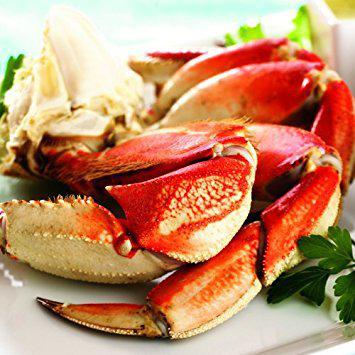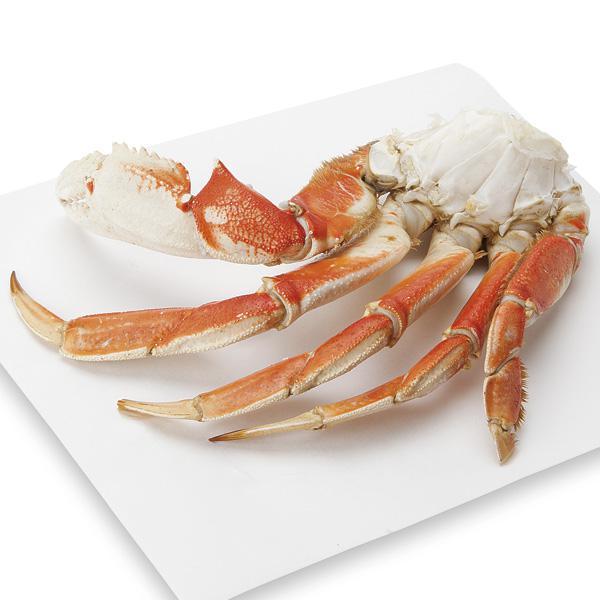The first image is the image on the left, the second image is the image on the right. Considering the images on both sides, is "In at least one image there is a total of five crab legs." valid? Answer yes or no. Yes. 